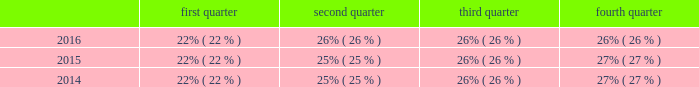Seasonality our business experiences seasonality that varies by product line .
Because more construction and do-it-yourself projects occur during the second and third calendar quarters of each year in the northern hemisphere , our security product sales , typically , are higher in those quarters than in the first and fourth calendar quarters .
However , our interflex business typically experiences higher sales in the fourth calendar quarter due to project timing .
Revenue by quarter for the years ended december 31 , 2016 , 2015 and 2014 are as follows: .
Employees as of december 31 , 2016 , we had more than 9400 employees .
Environmental regulation we have a dedicated environmental program that is designed to reduce the utilization and generation of hazardous materials during the manufacturing process as well as to remediate identified environmental concerns .
As to the latter , we are currently engaged in site investigations and remediation activities to address environmental cleanup from past operations at current and former production facilities .
The company regularly evaluates its remediation programs and considers alternative remediation methods that are in addition to , or in replacement of , those currently utilized by the company based upon enhanced technology and regulatory changes .
We are sometimes a party to environmental lawsuits and claims and have received notices of potential violations of environmental laws and regulations from the u.s .
Environmental protection agency ( the "epa" ) and similar state authorities .
We have also been identified as a potentially responsible party ( "prp" ) for cleanup costs associated with off-site waste disposal at federal superfund and state remediation sites .
For all such sites , there are other prps and , in most instances , our involvement is minimal .
In estimating our liability , we have assumed that we will not bear the entire cost of remediation of any site to the exclusion of other prps who may be jointly and severally liable .
The ability of other prps to participate has been taken into account , based on our understanding of the parties 2019 financial condition and probable contributions on a per site basis .
Additional lawsuits and claims involving environmental matters are likely to arise from time to time in the future .
We incurred $ 23.3 million , $ 4.4 million , and $ 2.9 million of expenses during the years ended december 31 , 2016 , 2015 , and 2014 , respectively , for environmental remediation at sites presently or formerly owned or leased by us .
As of december 31 , 2016 and 2015 , we have recorded reserves for environmental matters of $ 30.6 million and $ 15.2 million .
Of these amounts $ 9.6 million and $ 2.8 million , respectively , relate to remediation of sites previously disposed by us .
Given the evolving nature of environmental laws , regulations and technology , the ultimate cost of future compliance is uncertain .
Available information we are required to file annual , quarterly , and current reports , proxy statements , and other documents with the u.s .
Securities and exchange commission ( "sec" ) .
The public may read and copy any materials filed with the sec at the sec 2019s public reference room at 100 f street , n.e. , washington , d.c .
20549 .
The public may obtain information on the operation of the public reference room by calling the sec at 1-800-sec-0330 .
Also , the sec maintains an internet website that contains reports , proxy and information statements , and other information regarding issuers that file electronically with the sec .
The public can obtain any documents that are filed by us at http://www.sec.gov .
In addition , this annual report on form 10-k , as well as future quarterly reports on form 10-q , current reports on form 8-k and any amendments to all of the foregoing reports , are made available free of charge on our internet website ( http://www.allegion.com ) as soon as reasonably practicable after such reports are electronically filed with or furnished to the sec .
The contents of our website are not incorporated by reference in this report. .
Considering the year 2016 , what is the average revenue? 
Rationale: it is the sum of the revenue for all quarters , then divided by four .
Computations: table_average(2016, none)
Answer: 0.25. 